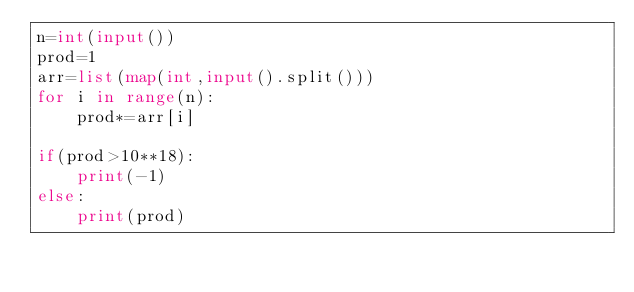<code> <loc_0><loc_0><loc_500><loc_500><_Python_>n=int(input())
prod=1
arr=list(map(int,input().split()))
for i in range(n):
    prod*=arr[i] 
    
if(prod>10**18):
    print(-1)
else:
    print(prod)</code> 